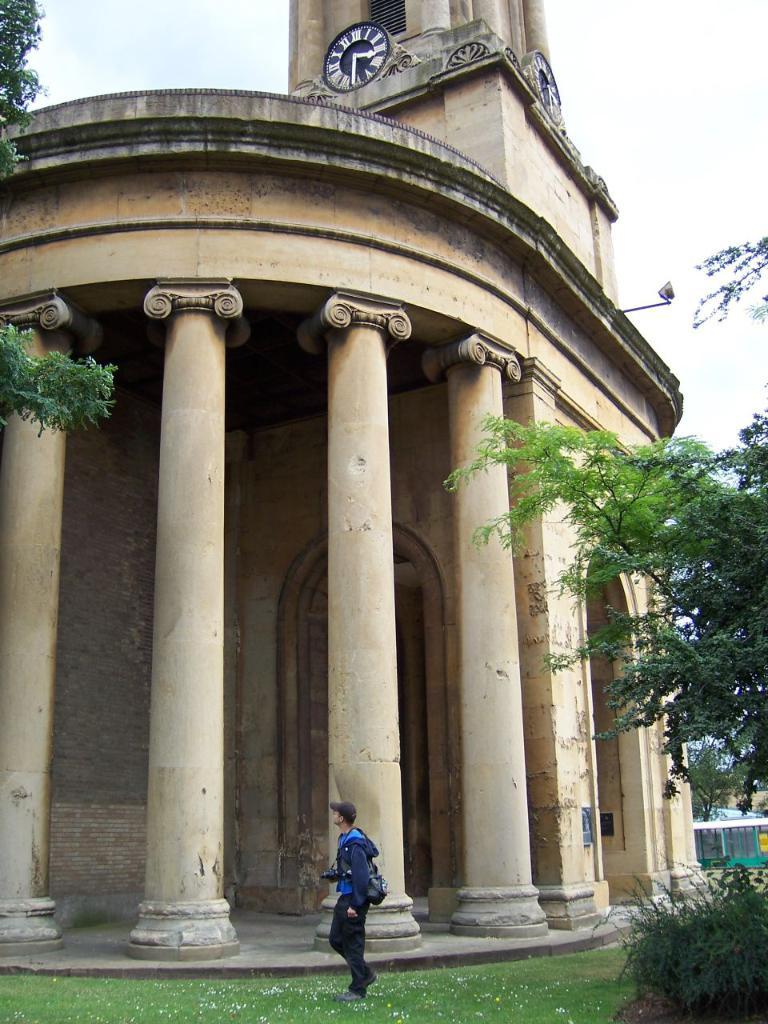What is the main subject in the image? There is a person standing in the image. What type of structure is visible in the image? There is a building with pillars and a clock in the image. What type of vegetation can be seen in the image? There are plants and trees in the image. What can be seen in the background of the image? The sky is visible in the background of the image. What type of flame can be seen in the image? There is no flame present in the image. What season is depicted in the image? The provided facts do not indicate a specific season, so it cannot be determined from the image. 